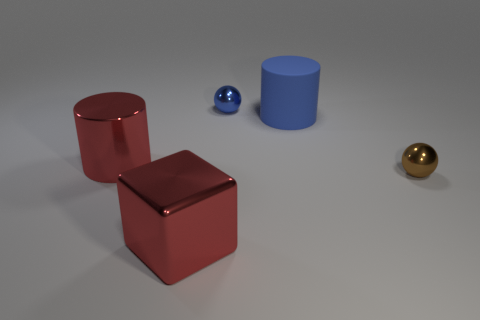Add 2 big green metal cylinders. How many objects exist? 7 Subtract all cylinders. How many objects are left? 3 Add 3 red metallic cubes. How many red metallic cubes exist? 4 Subtract 0 purple cubes. How many objects are left? 5 Subtract all tiny blue shiny balls. Subtract all tiny brown shiny balls. How many objects are left? 3 Add 1 big blue cylinders. How many big blue cylinders are left? 2 